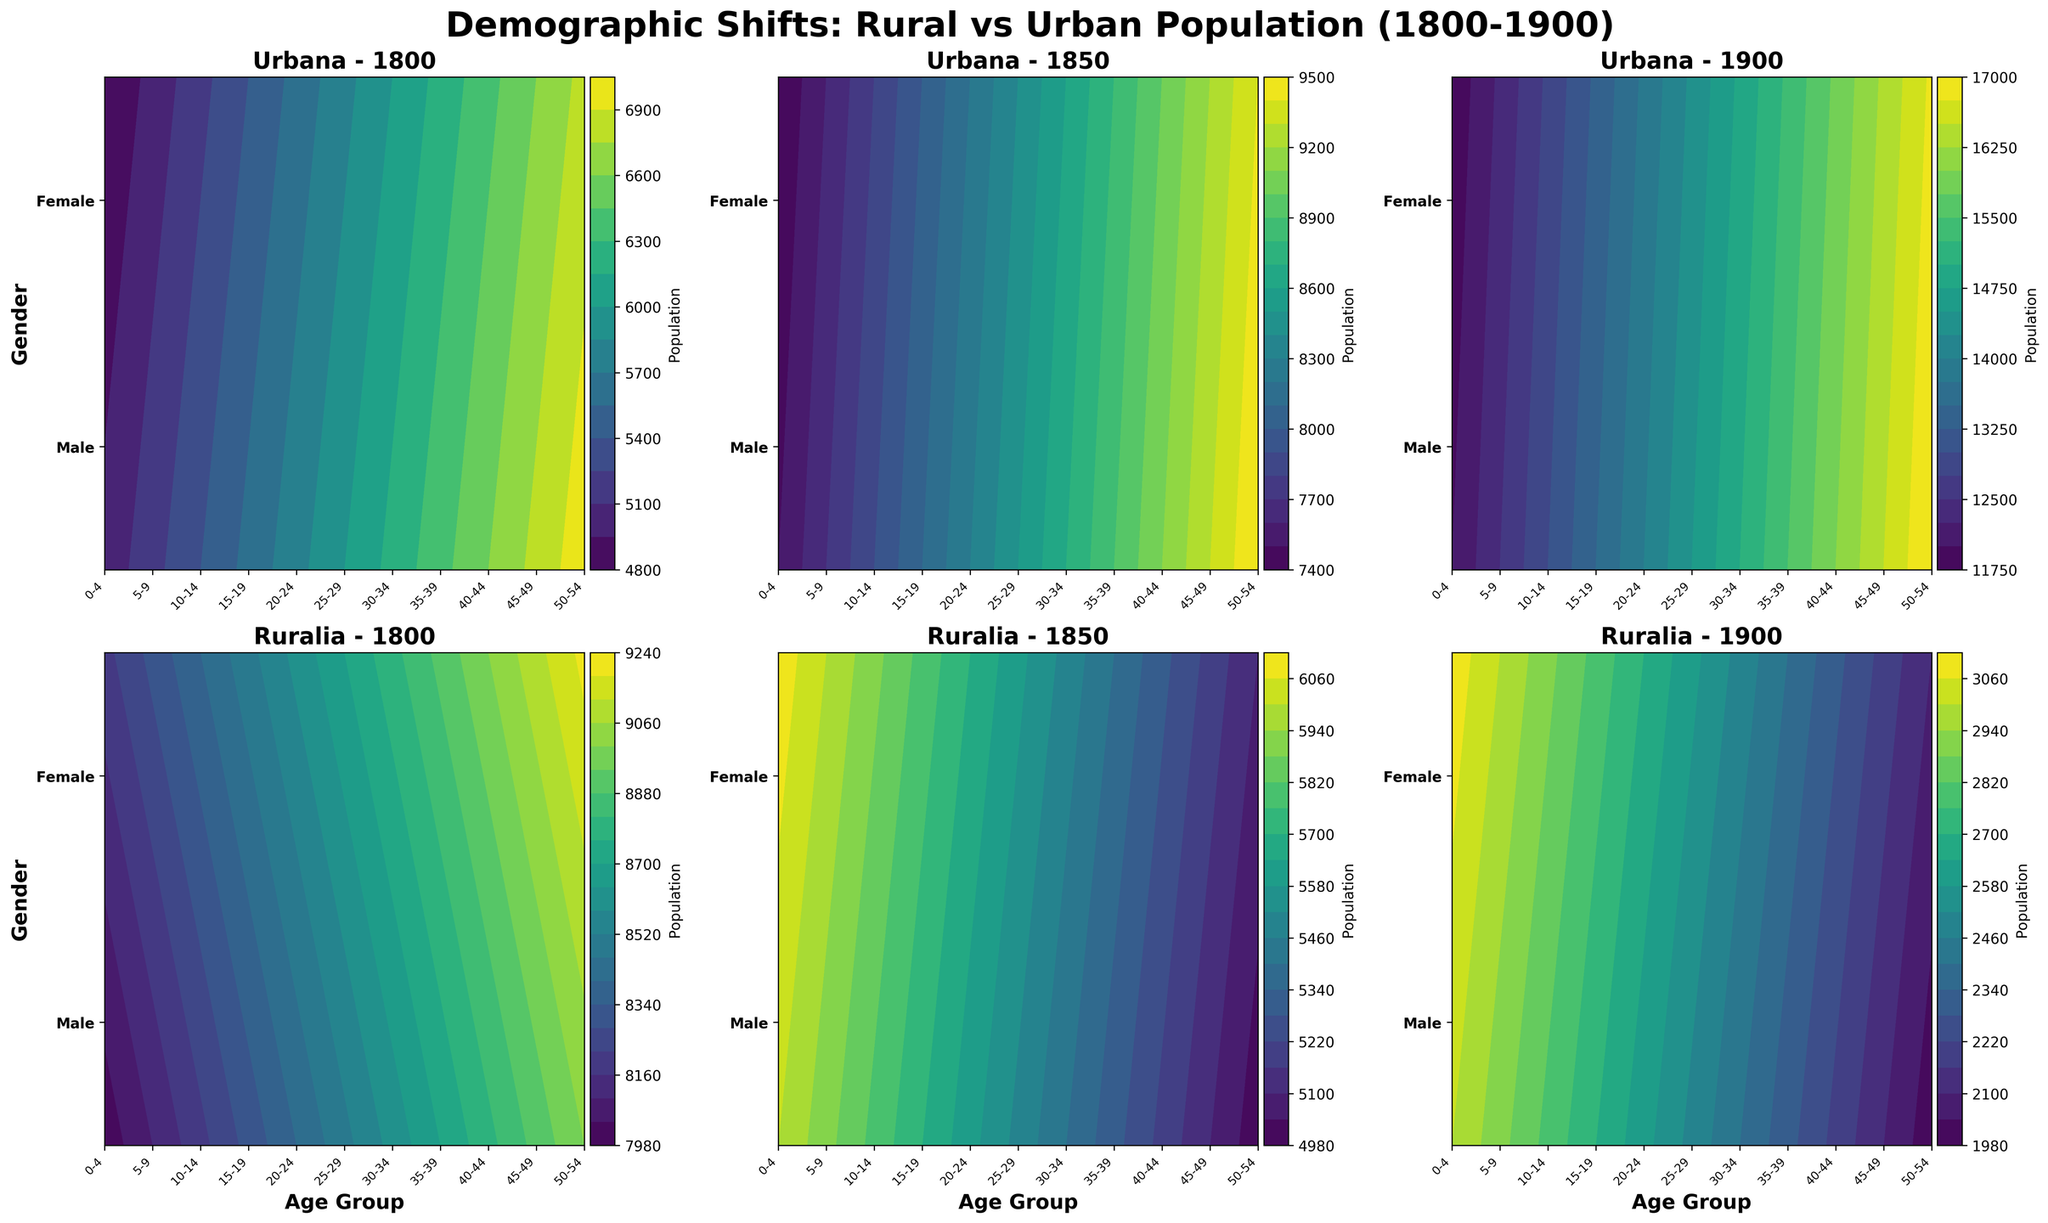What is the title of the figure? The title is prominently displayed at the top center of the figure. It reads "Demographic Shifts: Rural vs Urban Population (1800-1900)" and is in bold, large font.
Answer: Demographic Shifts: Rural vs Urban Population (1800-1900) What are the two areas compared in the figure? The two areas are labeled in each subplot's title, indicating either "Urbana" or "Ruralia."
Answer: Urbana and Ruralia How is the X-axis labeled? The X-axis is labeled with age groups, such as "0-4,” “5-9,” etc., and the labels are rotated at a 45-degree angle for readability.
Answer: Age group Which gender shows a higher population in Urbana in the year 1800 for the age group 0-4? The contour plot for Urbana in 1800 shows higher number when both the Male and Female population areas are compared visually for the age group 0-4.
Answer: Male How does the population trend of Ruralia change from 1800 to 1900? By comparing the subplots for the years 1800, 1850, and 1900 for Ruralia, you can see that the population density (color intensity) decreases significantly in 1900 for both males and females across all age groups.
Answer: It decreases What is the population count for females aged 50-54 in Urbana in the year 1850? Looking at the Urbana subplot for 1850, the population data for females aged 50-54 is provided directly.
Answer: 9400 Comparing 1800 and 1900, which age group in Urbana has shown the highest increase in population for males? By analyzing the change in color intensity between 1800 and 1900 in the Urbana subplots for males, the age groups can be compared. The most notable increase for males is in the 40-44 age group.
Answer: 40-44 Which area and gender combination experienced the most drastic population decline in the age category 0-4 from 1800 to 1900? Comparing the color intensity on the Ruralia subplots, the decline is more significant for males in the age category 0-4.
Answer: Ruralia, Male What color is predominantly used in the figure to indicate high population density? The contour plots use a color gradient with darker shades (e.g., darker tones in the viridis colormap) indicating higher population densities.
Answer: Darker shades 